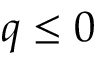Convert formula to latex. <formula><loc_0><loc_0><loc_500><loc_500>q \leq 0</formula> 